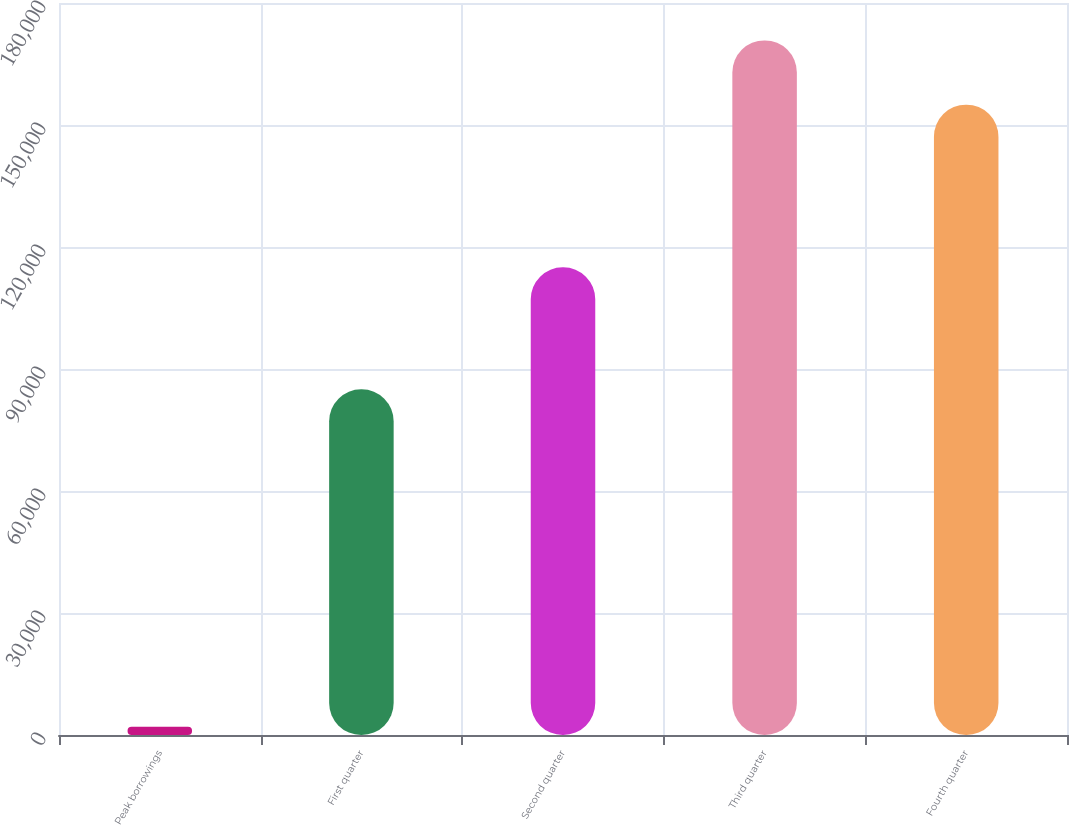Convert chart to OTSL. <chart><loc_0><loc_0><loc_500><loc_500><bar_chart><fcel>Peak borrowings<fcel>First quarter<fcel>Second quarter<fcel>Third quarter<fcel>Fourth quarter<nl><fcel>2014<fcel>85000<fcel>115000<fcel>170799<fcel>155000<nl></chart> 